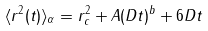Convert formula to latex. <formula><loc_0><loc_0><loc_500><loc_500>\langle r ^ { 2 } ( t ) \rangle _ { \alpha } = r _ { c } ^ { 2 } + A ( D t ) ^ { b } + 6 D t</formula> 